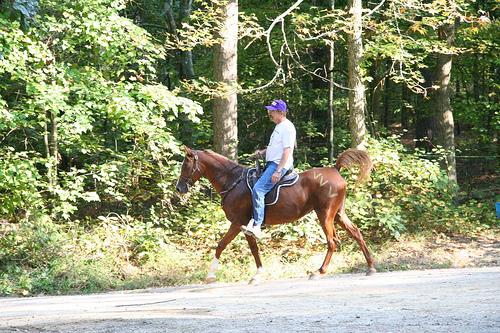What is the pattern on the horses rear?
Answer briefly. Vvv. Is the man on the horse wearing a hat?
Quick response, please. Yes. Is this area good for riding horses?
Be succinct. Yes. 